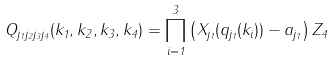Convert formula to latex. <formula><loc_0><loc_0><loc_500><loc_500>Q _ { j _ { 1 } j _ { 2 } j _ { 3 } j _ { 4 } } ( k _ { 1 } , k _ { 2 } , k _ { 3 } , k _ { 4 } ) = \prod _ { i = 1 } ^ { 3 } \left ( X _ { j _ { 1 } } ( q _ { j _ { 1 } } ( k _ { i } ) ) - a _ { j _ { 1 } } \right ) Z _ { 4 }</formula> 